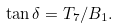<formula> <loc_0><loc_0><loc_500><loc_500>\tan \delta = T _ { 7 } / B _ { 1 } .</formula> 